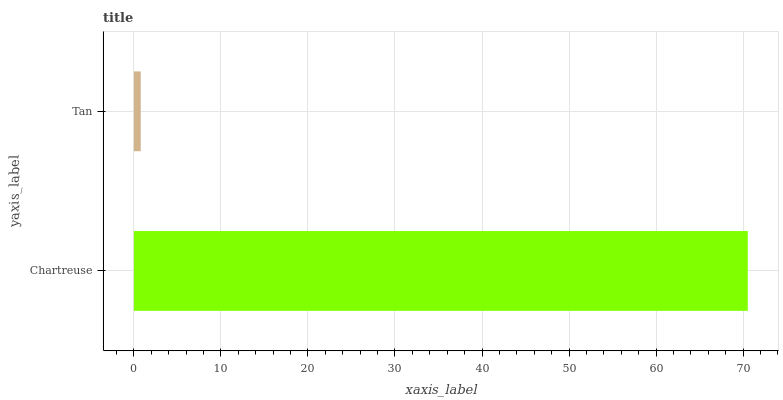Is Tan the minimum?
Answer yes or no. Yes. Is Chartreuse the maximum?
Answer yes or no. Yes. Is Tan the maximum?
Answer yes or no. No. Is Chartreuse greater than Tan?
Answer yes or no. Yes. Is Tan less than Chartreuse?
Answer yes or no. Yes. Is Tan greater than Chartreuse?
Answer yes or no. No. Is Chartreuse less than Tan?
Answer yes or no. No. Is Chartreuse the high median?
Answer yes or no. Yes. Is Tan the low median?
Answer yes or no. Yes. Is Tan the high median?
Answer yes or no. No. Is Chartreuse the low median?
Answer yes or no. No. 